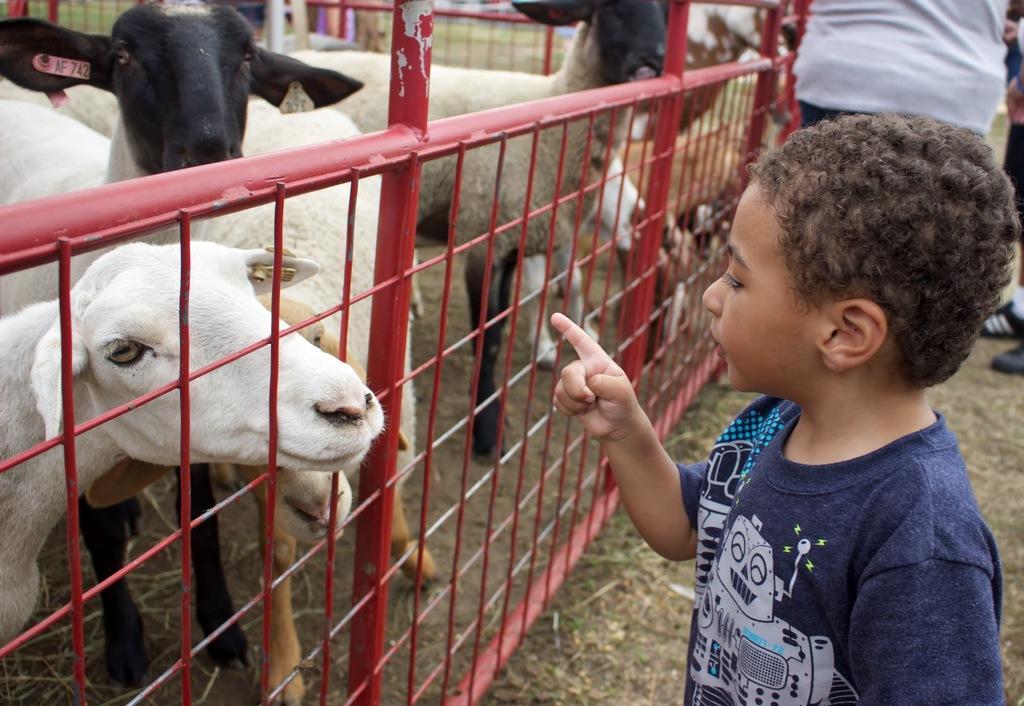Could you give a brief overview of what you see in this image? In the image we can see there is a herd of sheep and there is a kid standing and pointing finger to the sheep. Behind there are other people standing. 